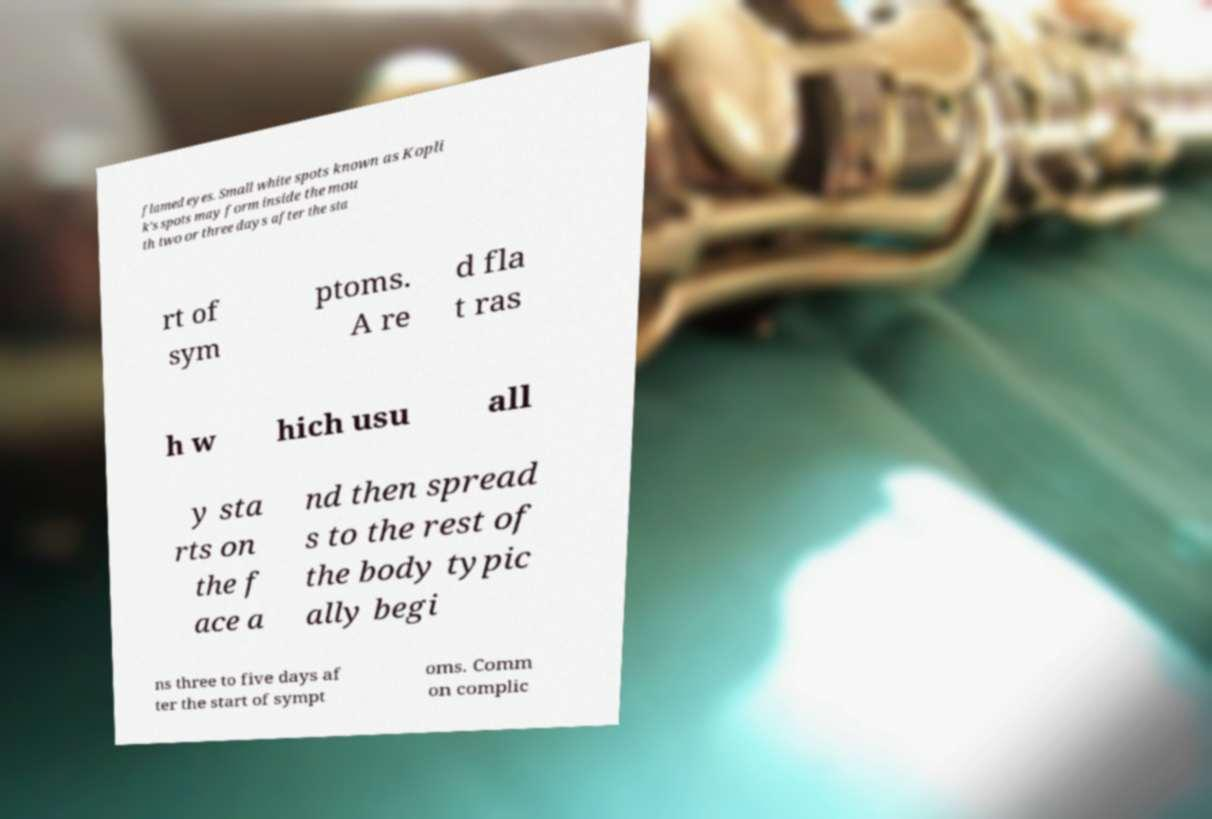Can you accurately transcribe the text from the provided image for me? flamed eyes. Small white spots known as Kopli k's spots may form inside the mou th two or three days after the sta rt of sym ptoms. A re d fla t ras h w hich usu all y sta rts on the f ace a nd then spread s to the rest of the body typic ally begi ns three to five days af ter the start of sympt oms. Comm on complic 